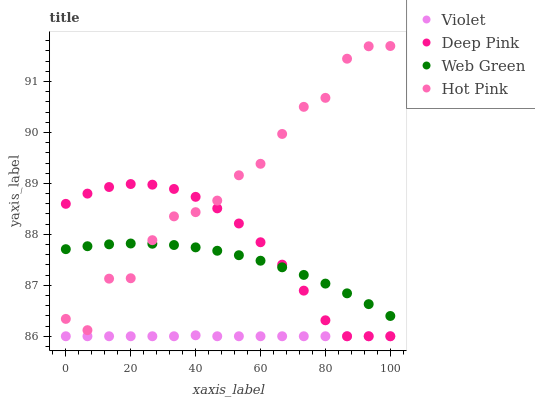Does Violet have the minimum area under the curve?
Answer yes or no. Yes. Does Hot Pink have the maximum area under the curve?
Answer yes or no. Yes. Does Deep Pink have the minimum area under the curve?
Answer yes or no. No. Does Deep Pink have the maximum area under the curve?
Answer yes or no. No. Is Violet the smoothest?
Answer yes or no. Yes. Is Hot Pink the roughest?
Answer yes or no. Yes. Is Deep Pink the smoothest?
Answer yes or no. No. Is Deep Pink the roughest?
Answer yes or no. No. Does Deep Pink have the lowest value?
Answer yes or no. Yes. Does Web Green have the lowest value?
Answer yes or no. No. Does Hot Pink have the highest value?
Answer yes or no. Yes. Does Deep Pink have the highest value?
Answer yes or no. No. Is Violet less than Web Green?
Answer yes or no. Yes. Is Hot Pink greater than Violet?
Answer yes or no. Yes. Does Hot Pink intersect Deep Pink?
Answer yes or no. Yes. Is Hot Pink less than Deep Pink?
Answer yes or no. No. Is Hot Pink greater than Deep Pink?
Answer yes or no. No. Does Violet intersect Web Green?
Answer yes or no. No. 